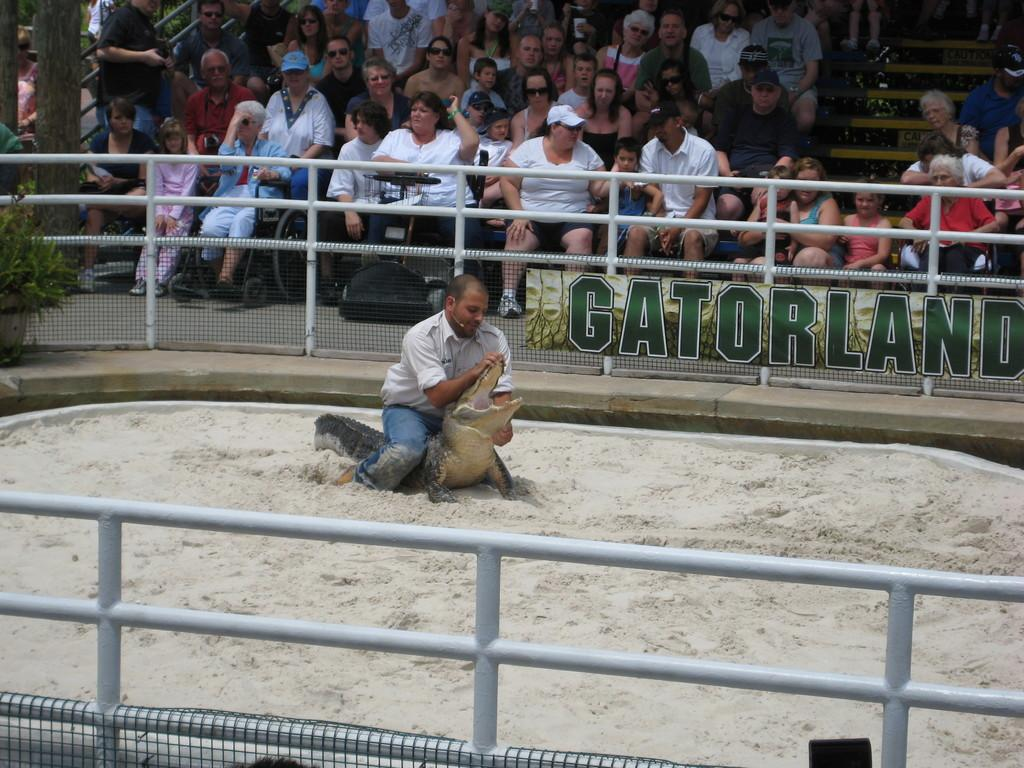What is the main subject of the image? There is a person in the image. What is the person wearing? The person is wearing clothes. What is the person doing in the image? The person is sitting on a crocodile. What can be seen in the background of the image? There is a crowd in front of the fencing. Are there any other fencing elements in the image? Yes, there is another fencing at the bottom of the image. What type of calculator is the dad using in the image? There is no dad or calculator present in the image. How does the drain affect the person sitting on the crocodile in the image? There is no drain present in the image, and therefore it cannot affect the person sitting on the crocodile. 